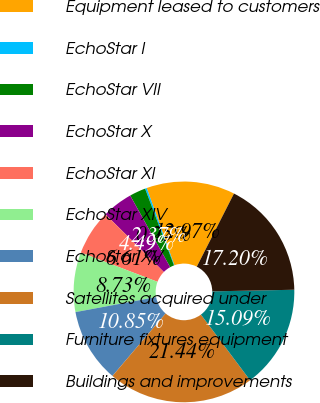Convert chart. <chart><loc_0><loc_0><loc_500><loc_500><pie_chart><fcel>Equipment leased to customers<fcel>EchoStar I<fcel>EchoStar VII<fcel>EchoStar X<fcel>EchoStar XI<fcel>EchoStar XIV<fcel>EchoStar XV<fcel>Satellites acquired under<fcel>Furniture fixtures equipment<fcel>Buildings and improvements<nl><fcel>12.97%<fcel>0.25%<fcel>2.37%<fcel>4.49%<fcel>6.61%<fcel>8.73%<fcel>10.85%<fcel>21.44%<fcel>15.09%<fcel>17.2%<nl></chart> 